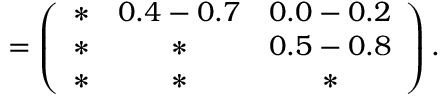<formula> <loc_0><loc_0><loc_500><loc_500>= \left ( \begin{array} { c c c } { \ast } & { 0 . 4 - 0 . 7 } & { 0 . 0 - 0 . 2 } \\ { \ast } & { \ast } & { 0 . 5 - 0 . 8 } \\ { \ast } & { \ast } & { \ast } \end{array} \right ) .</formula> 